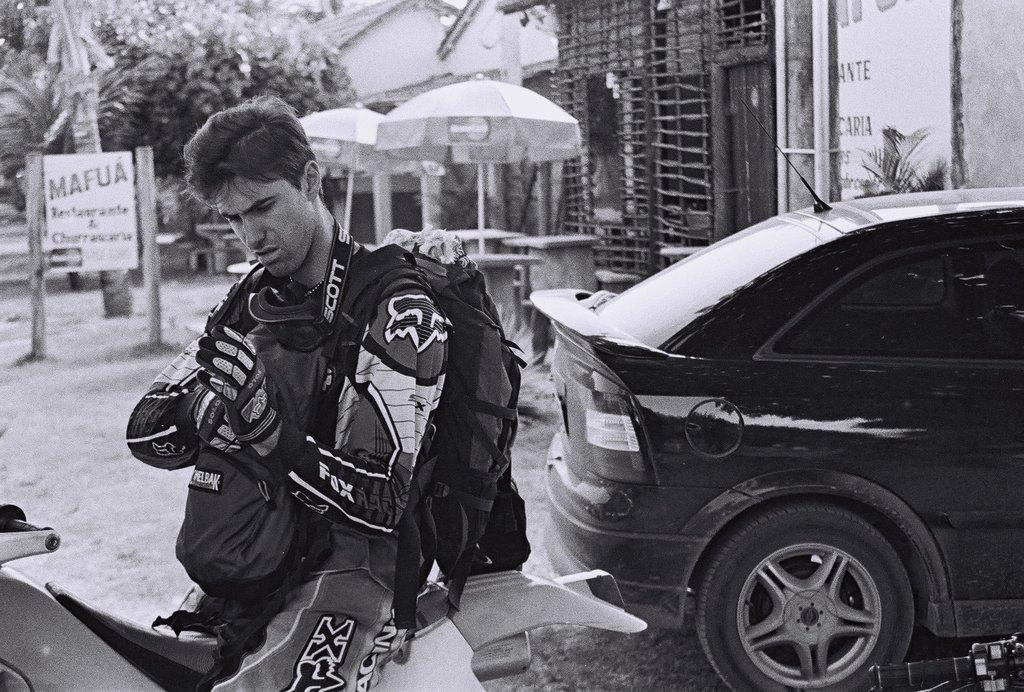What is the person in the image doing? The person is sitting on a bike in the image. What else can be seen in the image besides the person on the bike? There are vehicles visible in the image. What can be seen in the background of the image? The background of the image includes umbrellas, trees, and buildings. What is the color scheme of the image? The image is in black and white. What type of behavior is the person on the bike exhibiting in the image? The image does not provide information about the person's behavior; it only shows them sitting on a bike. How much does the bike cost in the image? The image does not provide information about the price of the bike. 